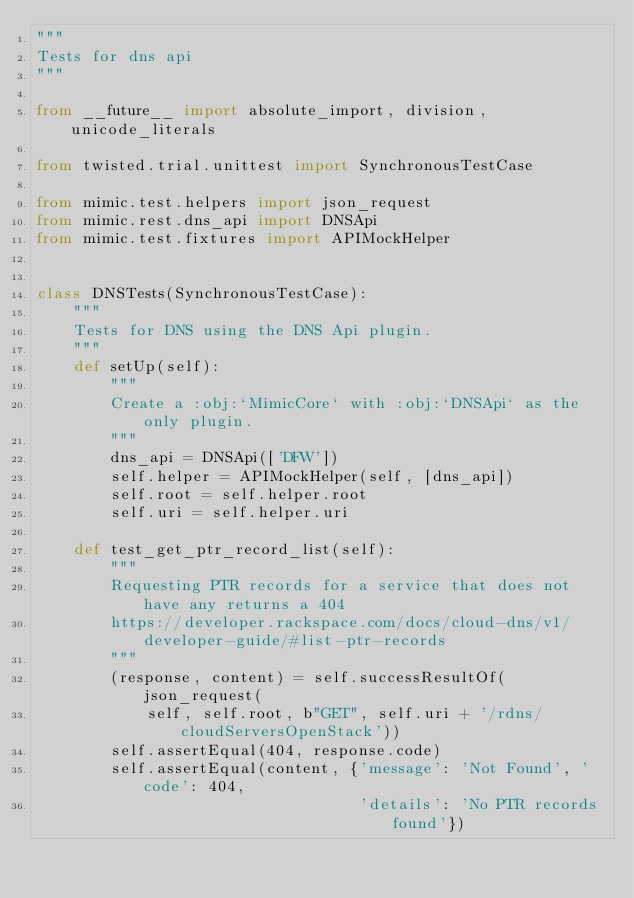Convert code to text. <code><loc_0><loc_0><loc_500><loc_500><_Python_>"""
Tests for dns api
"""

from __future__ import absolute_import, division, unicode_literals

from twisted.trial.unittest import SynchronousTestCase

from mimic.test.helpers import json_request
from mimic.rest.dns_api import DNSApi
from mimic.test.fixtures import APIMockHelper


class DNSTests(SynchronousTestCase):
    """
    Tests for DNS using the DNS Api plugin.
    """
    def setUp(self):
        """
        Create a :obj:`MimicCore` with :obj:`DNSApi` as the only plugin.
        """
        dns_api = DNSApi(['DFW'])
        self.helper = APIMockHelper(self, [dns_api])
        self.root = self.helper.root
        self.uri = self.helper.uri

    def test_get_ptr_record_list(self):
        """
        Requesting PTR records for a service that does not have any returns a 404
        https://developer.rackspace.com/docs/cloud-dns/v1/developer-guide/#list-ptr-records
        """
        (response, content) = self.successResultOf(json_request(
            self, self.root, b"GET", self.uri + '/rdns/cloudServersOpenStack'))
        self.assertEqual(404, response.code)
        self.assertEqual(content, {'message': 'Not Found', 'code': 404,
                                   'details': 'No PTR records found'})
</code> 